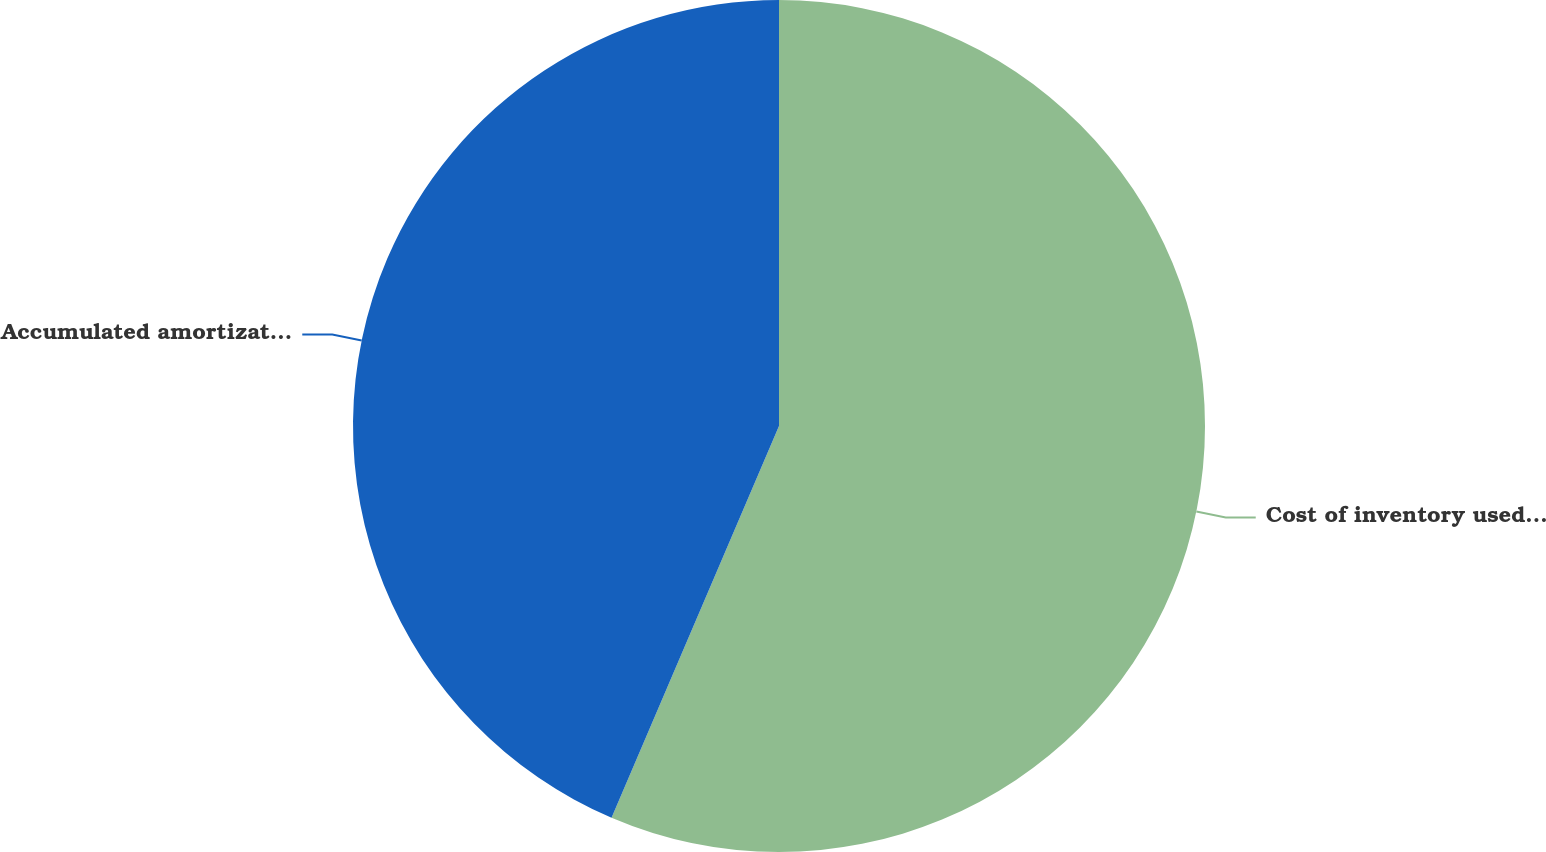Convert chart. <chart><loc_0><loc_0><loc_500><loc_500><pie_chart><fcel>Cost of inventory used for<fcel>Accumulated amortization<nl><fcel>56.43%<fcel>43.57%<nl></chart> 